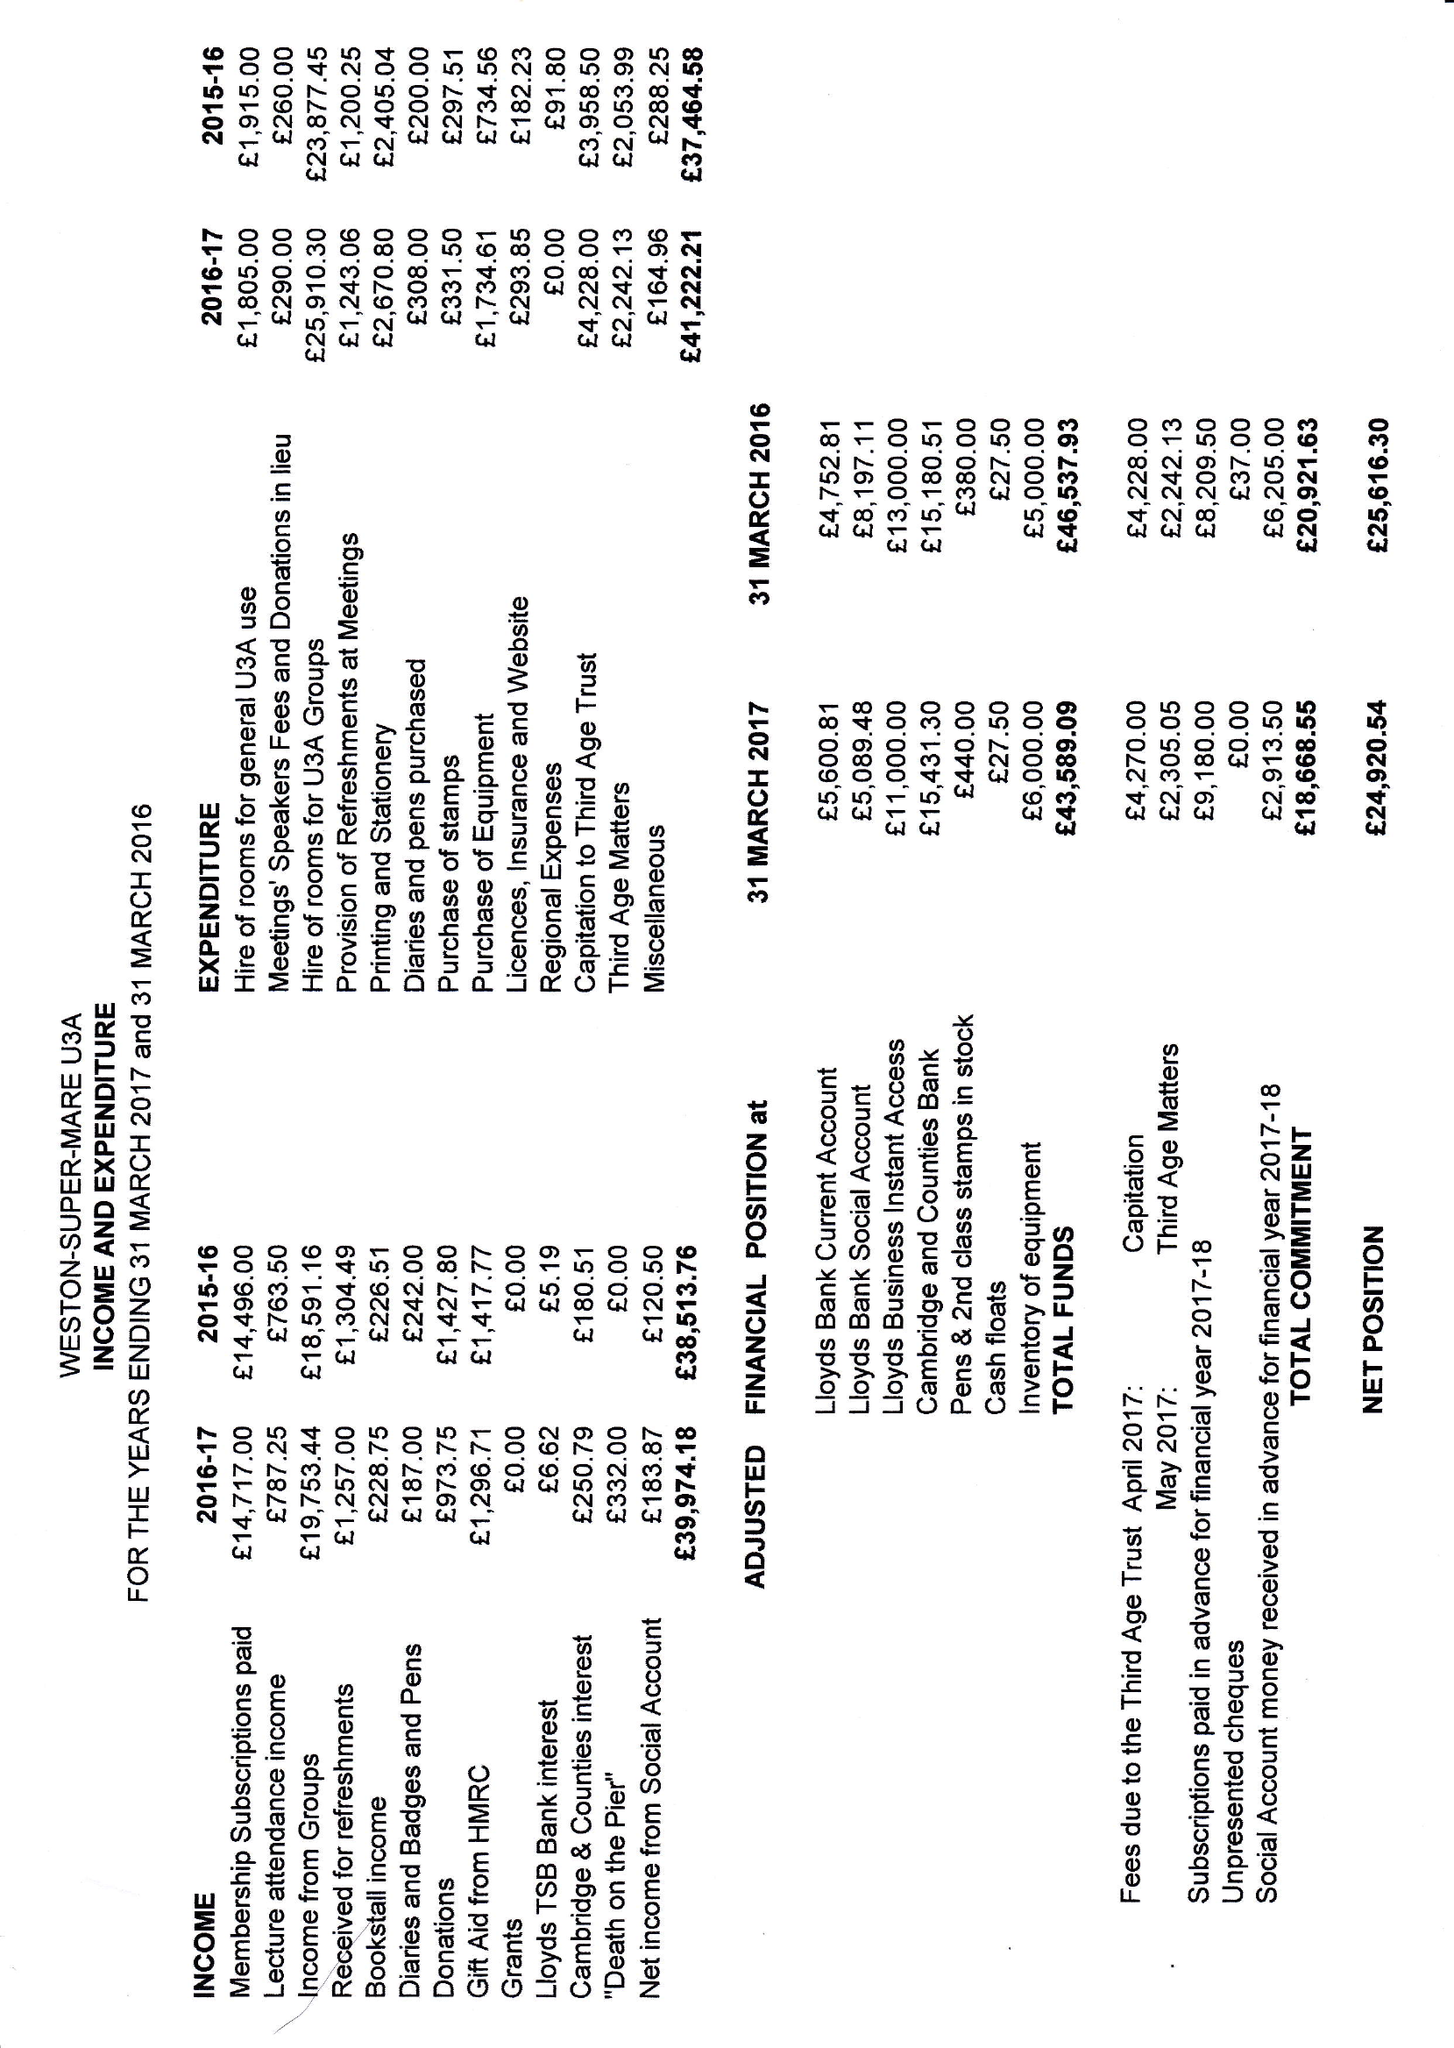What is the value for the address__post_town?
Answer the question using a single word or phrase. WESTON-SUPER-MARE 